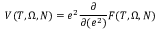<formula> <loc_0><loc_0><loc_500><loc_500>V ( T , \Omega , N ) = e ^ { 2 } \frac { \partial } { \partial ( e ^ { 2 } ) } F ( T , \Omega , N )</formula> 